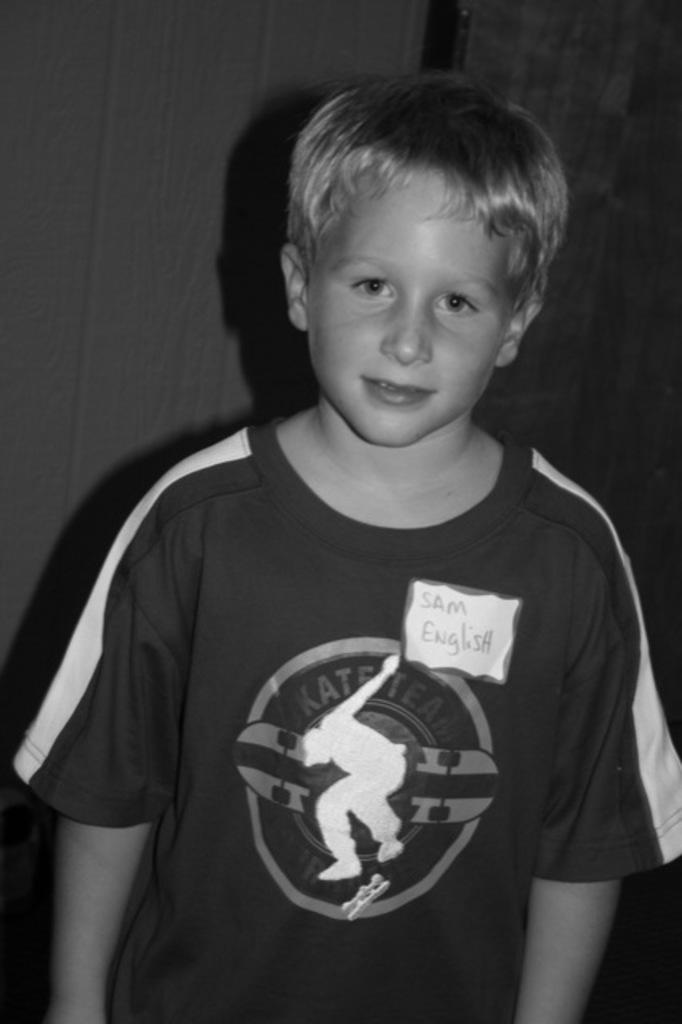What is the main subject of the image? There is a boy standing in the image. What can be seen in the background of the image? There is a wall in the background of the image. What decision is the boy making in the wilderness in the image? There is no wilderness present in the image, and the boy's decision-making process is not depicted. 